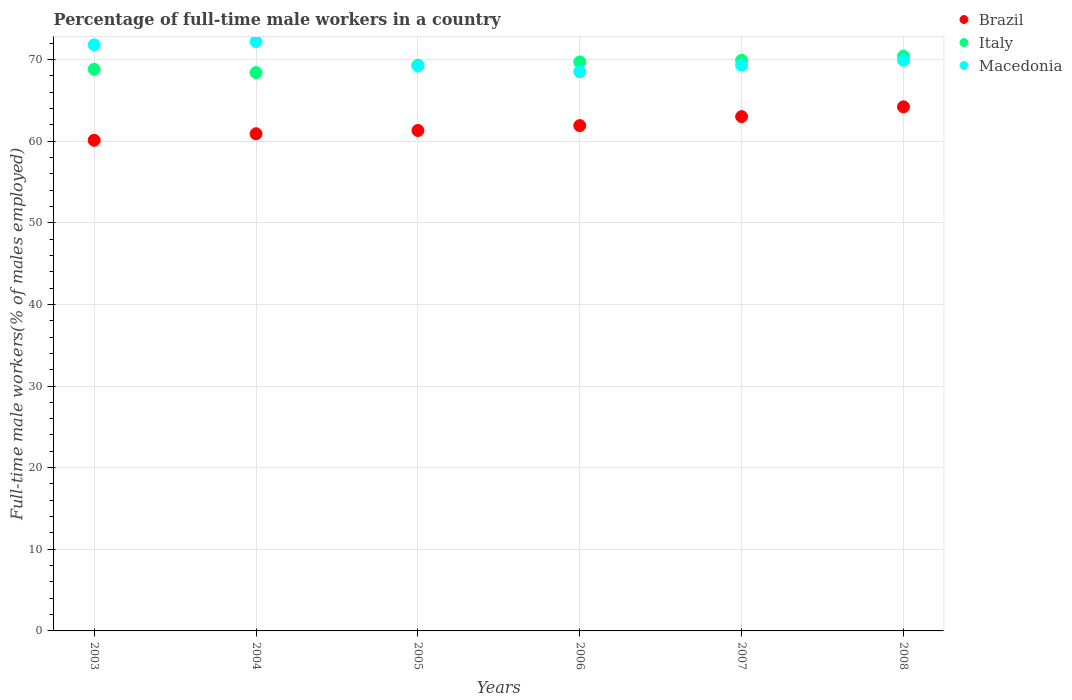Is the number of dotlines equal to the number of legend labels?
Offer a very short reply. Yes. What is the percentage of full-time male workers in Italy in 2006?
Your answer should be compact. 69.7. Across all years, what is the maximum percentage of full-time male workers in Macedonia?
Offer a very short reply. 72.2. Across all years, what is the minimum percentage of full-time male workers in Italy?
Keep it short and to the point. 68.4. In which year was the percentage of full-time male workers in Macedonia minimum?
Your answer should be very brief. 2006. What is the total percentage of full-time male workers in Brazil in the graph?
Keep it short and to the point. 371.4. What is the difference between the percentage of full-time male workers in Brazil in 2004 and that in 2006?
Make the answer very short. -1. What is the difference between the percentage of full-time male workers in Italy in 2004 and the percentage of full-time male workers in Macedonia in 2003?
Ensure brevity in your answer.  -3.4. What is the average percentage of full-time male workers in Macedonia per year?
Your answer should be compact. 70.15. In the year 2003, what is the difference between the percentage of full-time male workers in Italy and percentage of full-time male workers in Macedonia?
Make the answer very short. -3. What is the ratio of the percentage of full-time male workers in Italy in 2007 to that in 2008?
Provide a succinct answer. 0.99. What is the difference between the highest and the second highest percentage of full-time male workers in Italy?
Ensure brevity in your answer.  0.5. What is the difference between the highest and the lowest percentage of full-time male workers in Brazil?
Your answer should be compact. 4.1. Is the sum of the percentage of full-time male workers in Italy in 2003 and 2007 greater than the maximum percentage of full-time male workers in Macedonia across all years?
Give a very brief answer. Yes. Is it the case that in every year, the sum of the percentage of full-time male workers in Italy and percentage of full-time male workers in Macedonia  is greater than the percentage of full-time male workers in Brazil?
Keep it short and to the point. Yes. Is the percentage of full-time male workers in Macedonia strictly less than the percentage of full-time male workers in Brazil over the years?
Offer a terse response. No. How many dotlines are there?
Offer a very short reply. 3. How many years are there in the graph?
Keep it short and to the point. 6. Does the graph contain grids?
Make the answer very short. Yes. What is the title of the graph?
Keep it short and to the point. Percentage of full-time male workers in a country. Does "Vietnam" appear as one of the legend labels in the graph?
Ensure brevity in your answer.  No. What is the label or title of the X-axis?
Your response must be concise. Years. What is the label or title of the Y-axis?
Your answer should be very brief. Full-time male workers(% of males employed). What is the Full-time male workers(% of males employed) of Brazil in 2003?
Provide a succinct answer. 60.1. What is the Full-time male workers(% of males employed) in Italy in 2003?
Ensure brevity in your answer.  68.8. What is the Full-time male workers(% of males employed) of Macedonia in 2003?
Provide a succinct answer. 71.8. What is the Full-time male workers(% of males employed) in Brazil in 2004?
Provide a short and direct response. 60.9. What is the Full-time male workers(% of males employed) in Italy in 2004?
Your answer should be compact. 68.4. What is the Full-time male workers(% of males employed) in Macedonia in 2004?
Provide a short and direct response. 72.2. What is the Full-time male workers(% of males employed) in Brazil in 2005?
Your answer should be very brief. 61.3. What is the Full-time male workers(% of males employed) of Italy in 2005?
Your answer should be very brief. 69.3. What is the Full-time male workers(% of males employed) of Macedonia in 2005?
Your response must be concise. 69.2. What is the Full-time male workers(% of males employed) in Brazil in 2006?
Keep it short and to the point. 61.9. What is the Full-time male workers(% of males employed) in Italy in 2006?
Your response must be concise. 69.7. What is the Full-time male workers(% of males employed) of Macedonia in 2006?
Your answer should be very brief. 68.5. What is the Full-time male workers(% of males employed) of Brazil in 2007?
Give a very brief answer. 63. What is the Full-time male workers(% of males employed) of Italy in 2007?
Your answer should be very brief. 69.9. What is the Full-time male workers(% of males employed) in Macedonia in 2007?
Keep it short and to the point. 69.3. What is the Full-time male workers(% of males employed) in Brazil in 2008?
Your response must be concise. 64.2. What is the Full-time male workers(% of males employed) of Italy in 2008?
Give a very brief answer. 70.4. What is the Full-time male workers(% of males employed) of Macedonia in 2008?
Your answer should be very brief. 69.9. Across all years, what is the maximum Full-time male workers(% of males employed) in Brazil?
Make the answer very short. 64.2. Across all years, what is the maximum Full-time male workers(% of males employed) in Italy?
Offer a terse response. 70.4. Across all years, what is the maximum Full-time male workers(% of males employed) in Macedonia?
Make the answer very short. 72.2. Across all years, what is the minimum Full-time male workers(% of males employed) in Brazil?
Your answer should be very brief. 60.1. Across all years, what is the minimum Full-time male workers(% of males employed) of Italy?
Give a very brief answer. 68.4. Across all years, what is the minimum Full-time male workers(% of males employed) in Macedonia?
Your answer should be very brief. 68.5. What is the total Full-time male workers(% of males employed) in Brazil in the graph?
Give a very brief answer. 371.4. What is the total Full-time male workers(% of males employed) of Italy in the graph?
Offer a very short reply. 416.5. What is the total Full-time male workers(% of males employed) of Macedonia in the graph?
Ensure brevity in your answer.  420.9. What is the difference between the Full-time male workers(% of males employed) of Macedonia in 2003 and that in 2004?
Give a very brief answer. -0.4. What is the difference between the Full-time male workers(% of males employed) of Italy in 2003 and that in 2005?
Give a very brief answer. -0.5. What is the difference between the Full-time male workers(% of males employed) of Macedonia in 2003 and that in 2005?
Provide a succinct answer. 2.6. What is the difference between the Full-time male workers(% of males employed) in Brazil in 2003 and that in 2006?
Your answer should be very brief. -1.8. What is the difference between the Full-time male workers(% of males employed) of Italy in 2003 and that in 2006?
Give a very brief answer. -0.9. What is the difference between the Full-time male workers(% of males employed) in Italy in 2003 and that in 2007?
Give a very brief answer. -1.1. What is the difference between the Full-time male workers(% of males employed) of Macedonia in 2003 and that in 2007?
Ensure brevity in your answer.  2.5. What is the difference between the Full-time male workers(% of males employed) of Macedonia in 2003 and that in 2008?
Offer a very short reply. 1.9. What is the difference between the Full-time male workers(% of males employed) of Italy in 2004 and that in 2005?
Your answer should be very brief. -0.9. What is the difference between the Full-time male workers(% of males employed) in Macedonia in 2004 and that in 2005?
Offer a terse response. 3. What is the difference between the Full-time male workers(% of males employed) in Italy in 2004 and that in 2006?
Your response must be concise. -1.3. What is the difference between the Full-time male workers(% of males employed) in Italy in 2004 and that in 2007?
Provide a short and direct response. -1.5. What is the difference between the Full-time male workers(% of males employed) in Macedonia in 2004 and that in 2007?
Your response must be concise. 2.9. What is the difference between the Full-time male workers(% of males employed) of Brazil in 2004 and that in 2008?
Offer a very short reply. -3.3. What is the difference between the Full-time male workers(% of males employed) in Italy in 2004 and that in 2008?
Make the answer very short. -2. What is the difference between the Full-time male workers(% of males employed) of Italy in 2005 and that in 2006?
Keep it short and to the point. -0.4. What is the difference between the Full-time male workers(% of males employed) of Macedonia in 2005 and that in 2006?
Offer a very short reply. 0.7. What is the difference between the Full-time male workers(% of males employed) in Brazil in 2006 and that in 2007?
Your answer should be compact. -1.1. What is the difference between the Full-time male workers(% of males employed) of Macedonia in 2006 and that in 2007?
Offer a very short reply. -0.8. What is the difference between the Full-time male workers(% of males employed) of Macedonia in 2006 and that in 2008?
Offer a terse response. -1.4. What is the difference between the Full-time male workers(% of males employed) of Italy in 2007 and that in 2008?
Keep it short and to the point. -0.5. What is the difference between the Full-time male workers(% of males employed) of Brazil in 2003 and the Full-time male workers(% of males employed) of Italy in 2004?
Ensure brevity in your answer.  -8.3. What is the difference between the Full-time male workers(% of males employed) in Brazil in 2003 and the Full-time male workers(% of males employed) in Italy in 2005?
Ensure brevity in your answer.  -9.2. What is the difference between the Full-time male workers(% of males employed) in Italy in 2003 and the Full-time male workers(% of males employed) in Macedonia in 2005?
Your answer should be compact. -0.4. What is the difference between the Full-time male workers(% of males employed) of Brazil in 2003 and the Full-time male workers(% of males employed) of Italy in 2006?
Your response must be concise. -9.6. What is the difference between the Full-time male workers(% of males employed) in Brazil in 2003 and the Full-time male workers(% of males employed) in Macedonia in 2006?
Make the answer very short. -8.4. What is the difference between the Full-time male workers(% of males employed) of Brazil in 2003 and the Full-time male workers(% of males employed) of Italy in 2007?
Offer a terse response. -9.8. What is the difference between the Full-time male workers(% of males employed) in Brazil in 2003 and the Full-time male workers(% of males employed) in Macedonia in 2007?
Your answer should be compact. -9.2. What is the difference between the Full-time male workers(% of males employed) of Brazil in 2003 and the Full-time male workers(% of males employed) of Macedonia in 2008?
Make the answer very short. -9.8. What is the difference between the Full-time male workers(% of males employed) of Brazil in 2004 and the Full-time male workers(% of males employed) of Italy in 2005?
Provide a short and direct response. -8.4. What is the difference between the Full-time male workers(% of males employed) in Italy in 2004 and the Full-time male workers(% of males employed) in Macedonia in 2005?
Provide a short and direct response. -0.8. What is the difference between the Full-time male workers(% of males employed) in Brazil in 2004 and the Full-time male workers(% of males employed) in Italy in 2006?
Make the answer very short. -8.8. What is the difference between the Full-time male workers(% of males employed) of Brazil in 2004 and the Full-time male workers(% of males employed) of Macedonia in 2007?
Your answer should be compact. -8.4. What is the difference between the Full-time male workers(% of males employed) in Brazil in 2005 and the Full-time male workers(% of males employed) in Italy in 2006?
Offer a terse response. -8.4. What is the difference between the Full-time male workers(% of males employed) in Brazil in 2005 and the Full-time male workers(% of males employed) in Macedonia in 2007?
Your answer should be compact. -8. What is the difference between the Full-time male workers(% of males employed) of Brazil in 2005 and the Full-time male workers(% of males employed) of Italy in 2008?
Offer a terse response. -9.1. What is the difference between the Full-time male workers(% of males employed) in Brazil in 2006 and the Full-time male workers(% of males employed) in Macedonia in 2007?
Provide a short and direct response. -7.4. What is the difference between the Full-time male workers(% of males employed) of Italy in 2006 and the Full-time male workers(% of males employed) of Macedonia in 2007?
Provide a short and direct response. 0.4. What is the difference between the Full-time male workers(% of males employed) of Brazil in 2006 and the Full-time male workers(% of males employed) of Macedonia in 2008?
Give a very brief answer. -8. What is the difference between the Full-time male workers(% of males employed) in Italy in 2006 and the Full-time male workers(% of males employed) in Macedonia in 2008?
Offer a terse response. -0.2. What is the difference between the Full-time male workers(% of males employed) of Brazil in 2007 and the Full-time male workers(% of males employed) of Italy in 2008?
Your response must be concise. -7.4. What is the difference between the Full-time male workers(% of males employed) in Italy in 2007 and the Full-time male workers(% of males employed) in Macedonia in 2008?
Keep it short and to the point. 0. What is the average Full-time male workers(% of males employed) of Brazil per year?
Give a very brief answer. 61.9. What is the average Full-time male workers(% of males employed) in Italy per year?
Your answer should be compact. 69.42. What is the average Full-time male workers(% of males employed) in Macedonia per year?
Provide a short and direct response. 70.15. In the year 2003, what is the difference between the Full-time male workers(% of males employed) in Brazil and Full-time male workers(% of males employed) in Macedonia?
Your response must be concise. -11.7. In the year 2003, what is the difference between the Full-time male workers(% of males employed) in Italy and Full-time male workers(% of males employed) in Macedonia?
Offer a very short reply. -3. In the year 2004, what is the difference between the Full-time male workers(% of males employed) in Italy and Full-time male workers(% of males employed) in Macedonia?
Your response must be concise. -3.8. In the year 2005, what is the difference between the Full-time male workers(% of males employed) of Brazil and Full-time male workers(% of males employed) of Italy?
Make the answer very short. -8. In the year 2005, what is the difference between the Full-time male workers(% of males employed) in Brazil and Full-time male workers(% of males employed) in Macedonia?
Your answer should be compact. -7.9. In the year 2006, what is the difference between the Full-time male workers(% of males employed) of Brazil and Full-time male workers(% of males employed) of Italy?
Give a very brief answer. -7.8. In the year 2006, what is the difference between the Full-time male workers(% of males employed) of Brazil and Full-time male workers(% of males employed) of Macedonia?
Give a very brief answer. -6.6. In the year 2006, what is the difference between the Full-time male workers(% of males employed) of Italy and Full-time male workers(% of males employed) of Macedonia?
Ensure brevity in your answer.  1.2. In the year 2007, what is the difference between the Full-time male workers(% of males employed) of Italy and Full-time male workers(% of males employed) of Macedonia?
Make the answer very short. 0.6. In the year 2008, what is the difference between the Full-time male workers(% of males employed) of Italy and Full-time male workers(% of males employed) of Macedonia?
Ensure brevity in your answer.  0.5. What is the ratio of the Full-time male workers(% of males employed) in Brazil in 2003 to that in 2004?
Your answer should be very brief. 0.99. What is the ratio of the Full-time male workers(% of males employed) in Macedonia in 2003 to that in 2004?
Your response must be concise. 0.99. What is the ratio of the Full-time male workers(% of males employed) in Brazil in 2003 to that in 2005?
Offer a very short reply. 0.98. What is the ratio of the Full-time male workers(% of males employed) of Macedonia in 2003 to that in 2005?
Provide a succinct answer. 1.04. What is the ratio of the Full-time male workers(% of males employed) in Brazil in 2003 to that in 2006?
Ensure brevity in your answer.  0.97. What is the ratio of the Full-time male workers(% of males employed) in Italy in 2003 to that in 2006?
Your answer should be compact. 0.99. What is the ratio of the Full-time male workers(% of males employed) of Macedonia in 2003 to that in 2006?
Make the answer very short. 1.05. What is the ratio of the Full-time male workers(% of males employed) in Brazil in 2003 to that in 2007?
Offer a very short reply. 0.95. What is the ratio of the Full-time male workers(% of males employed) in Italy in 2003 to that in 2007?
Your answer should be very brief. 0.98. What is the ratio of the Full-time male workers(% of males employed) of Macedonia in 2003 to that in 2007?
Offer a terse response. 1.04. What is the ratio of the Full-time male workers(% of males employed) of Brazil in 2003 to that in 2008?
Offer a terse response. 0.94. What is the ratio of the Full-time male workers(% of males employed) in Italy in 2003 to that in 2008?
Your answer should be very brief. 0.98. What is the ratio of the Full-time male workers(% of males employed) in Macedonia in 2003 to that in 2008?
Ensure brevity in your answer.  1.03. What is the ratio of the Full-time male workers(% of males employed) of Macedonia in 2004 to that in 2005?
Keep it short and to the point. 1.04. What is the ratio of the Full-time male workers(% of males employed) in Brazil in 2004 to that in 2006?
Ensure brevity in your answer.  0.98. What is the ratio of the Full-time male workers(% of males employed) in Italy in 2004 to that in 2006?
Your answer should be compact. 0.98. What is the ratio of the Full-time male workers(% of males employed) of Macedonia in 2004 to that in 2006?
Make the answer very short. 1.05. What is the ratio of the Full-time male workers(% of males employed) of Brazil in 2004 to that in 2007?
Keep it short and to the point. 0.97. What is the ratio of the Full-time male workers(% of males employed) in Italy in 2004 to that in 2007?
Make the answer very short. 0.98. What is the ratio of the Full-time male workers(% of males employed) of Macedonia in 2004 to that in 2007?
Ensure brevity in your answer.  1.04. What is the ratio of the Full-time male workers(% of males employed) of Brazil in 2004 to that in 2008?
Provide a succinct answer. 0.95. What is the ratio of the Full-time male workers(% of males employed) in Italy in 2004 to that in 2008?
Give a very brief answer. 0.97. What is the ratio of the Full-time male workers(% of males employed) in Macedonia in 2004 to that in 2008?
Make the answer very short. 1.03. What is the ratio of the Full-time male workers(% of males employed) in Brazil in 2005 to that in 2006?
Provide a succinct answer. 0.99. What is the ratio of the Full-time male workers(% of males employed) of Macedonia in 2005 to that in 2006?
Make the answer very short. 1.01. What is the ratio of the Full-time male workers(% of males employed) of Italy in 2005 to that in 2007?
Give a very brief answer. 0.99. What is the ratio of the Full-time male workers(% of males employed) in Macedonia in 2005 to that in 2007?
Give a very brief answer. 1. What is the ratio of the Full-time male workers(% of males employed) in Brazil in 2005 to that in 2008?
Offer a terse response. 0.95. What is the ratio of the Full-time male workers(% of males employed) of Italy in 2005 to that in 2008?
Ensure brevity in your answer.  0.98. What is the ratio of the Full-time male workers(% of males employed) in Brazil in 2006 to that in 2007?
Keep it short and to the point. 0.98. What is the ratio of the Full-time male workers(% of males employed) in Brazil in 2006 to that in 2008?
Your answer should be very brief. 0.96. What is the ratio of the Full-time male workers(% of males employed) in Italy in 2006 to that in 2008?
Ensure brevity in your answer.  0.99. What is the ratio of the Full-time male workers(% of males employed) of Macedonia in 2006 to that in 2008?
Offer a very short reply. 0.98. What is the ratio of the Full-time male workers(% of males employed) of Brazil in 2007 to that in 2008?
Provide a succinct answer. 0.98. What is the ratio of the Full-time male workers(% of males employed) of Italy in 2007 to that in 2008?
Make the answer very short. 0.99. What is the ratio of the Full-time male workers(% of males employed) of Macedonia in 2007 to that in 2008?
Keep it short and to the point. 0.99. What is the difference between the highest and the second highest Full-time male workers(% of males employed) of Brazil?
Your answer should be compact. 1.2. What is the difference between the highest and the second highest Full-time male workers(% of males employed) in Italy?
Your answer should be very brief. 0.5. What is the difference between the highest and the second highest Full-time male workers(% of males employed) in Macedonia?
Offer a very short reply. 0.4. What is the difference between the highest and the lowest Full-time male workers(% of males employed) of Brazil?
Provide a succinct answer. 4.1. What is the difference between the highest and the lowest Full-time male workers(% of males employed) of Italy?
Offer a terse response. 2. 